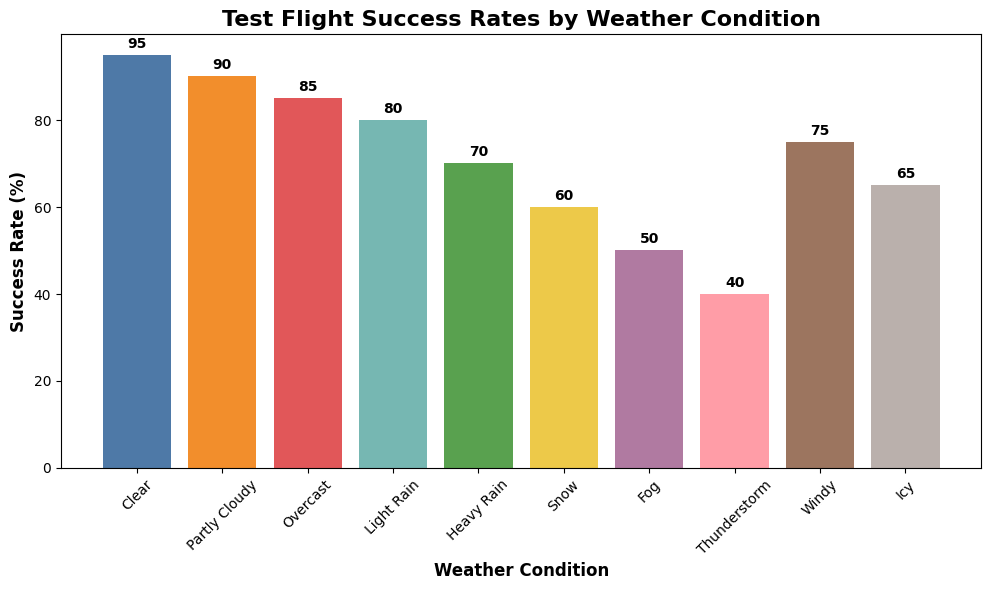Which weather condition has the highest test flight success rate? First, observe the labels on the x-axis, identifying each weather condition. Then, look at the height of each corresponding bar. The tallest bar indicates the highest success rate. Clear skies have the tallest bar.
Answer: Clear Which weather condition has a lower success rate: windy or icy? Observe the bars labeled 'Windy' and 'Icy' on the x-axis. Compare their heights. The 'Windy' bar is taller than the 'Icy' bar, indicating that windy weather has a higher success rate.
Answer: Icy What is the difference in success rates between light rain and heavy rain? First, identify the bars for 'Light Rain' and 'Heavy Rain' on the x-axis and note their heights. Light rain has a success rate of 80%, while heavy rain has 70%. Subtract the success rate of heavy rain from light rain: 80% - 70% = 10%.
Answer: 10% What is the average success rate for clear, partly cloudy, and overcast conditions? Identify the success rates for clear (95%), partly cloudy (90%), and overcast (85%). Sum these values: 95 + 90 + 85 = 270. Then, divide by the number of conditions (3): 270 / 3 = 90%.
Answer: 90% Which weather condition falls in the middle in terms of success rate? Arrange the success rates in ascending order: 40%, 50%, 60%, 65%, 70%, 75%, 80%, 85%, 90%, and 95%. With ten conditions, the median will be the average of the 5th and 6th values. The middle values are 70% and 75%, so the median is (70 + 75) / 2 = 72.5%. The condition closest to this is Windy (75%).
Answer: Windy How many weather conditions have a success rate above 80%? Identify the bars that exceed the 80% mark. These correspond to clear (95%), partly cloudy (90%), and overcast (85%) conditions. Count these bars: 3 weather conditions.
Answer: 3 What is the combined success rate for snow and fog conditions? Find the success rates for snow (60%) and fog (50%). Add these values together: 60 + 50 = 110%.
Answer: 110% Is the success rate for thunderstorms less than that for fog? Compare the height of the bars for 'Thunderstorm' and 'Fog'. The 'Thunderstorm' bar is smaller, indicating a lower success rate.
Answer: Yes Which weather condition has a success rate greater than icy but less than light rain? Find the success rates for 'Icy' (65%) and 'Light Rain' (80%). Locate the bar between these two values. The 'Windy' bar fits this range with a 75% success rate.
Answer: Windy What is the success rate for thunderstorms compared to snow? Identify the bars for 'Thunderstorm' (40%) and 'Snow' (60%). Compare their heights. The thunderstorm rate is lower than the snow rate.
Answer: Lower 